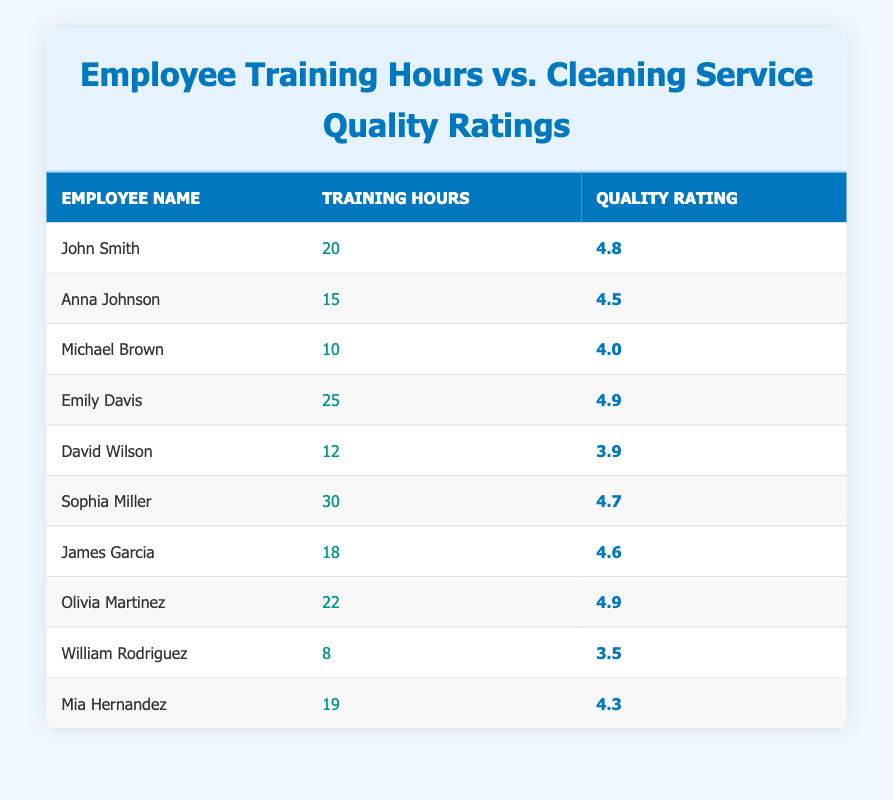What is the highest Quality Rating among the employees? The table shows the Quality Ratings for each employee. The highest rating is 4.9, provided by Emily Davis and Olivia Martinez.
Answer: 4.9 Which employee has the most Training Hours? By examining the Training Hours column, Sophia Miller has 30 hours, which is the highest among all employees.
Answer: Sophia Miller What is the average Training Hours for all employees? To find the average, sum all the Training Hours (20 + 15 + 10 + 25 + 12 + 30 + 18 + 22 + 8 + 19 =  189) and divide by the total number of employees (10). The average is 189 / 10 = 18.9.
Answer: 18.9 Is there an employee with less than 10 Training Hours? Looking at the Training Hours column, William Rodriguez has 8 hours, indicating there is indeed an employee with less than 10 hours.
Answer: Yes How many employees have a Quality Rating above 4.5? First, we check each employee's Quality Rating. The employees with ratings above 4.5 are John Smith, Emily Davis, Sophia Miller, James Garcia, and Olivia Martinez, totaling 5 employees.
Answer: 5 What is the difference in Quality Ratings between the employee with the most and the least Training Hours? The employee with the least Training Hours is William Rodriguez with a Quality Rating of 3.5, while the one with the most, Sophia Miller, has a Quality Rating of 4.7. The difference is 4.7 - 3.5 = 1.2.
Answer: 1.2 Who has a Quality Rating lower than 4 but more than 10 Training Hours? Checking the table, we see that Michael Brown has a Quality Rating of 4.0 and 10 Training Hours, and David Wilson has a Quality Rating of 3.9 but has more than 10 (12 hours). Thus, David Wilson meets the criteria.
Answer: David Wilson What are the Quality Ratings for the three employees with the least Training Hours? The employees with the least Training Hours are: William Rodriguez (3.5), Michael Brown (4.0), and David Wilson (3.9). Thus, their ratings are 3.5, 4.0, and 3.9, respectively.
Answer: 3.5, 4.0, 3.9 Does increased Training Hours correlate with higher Quality Ratings? Using the data, as Training Hours increase, Quality Ratings generally increase as well. Although not a strict rule, most employees with higher hours have higher ratings, indicating a positive correlation.
Answer: Yes 